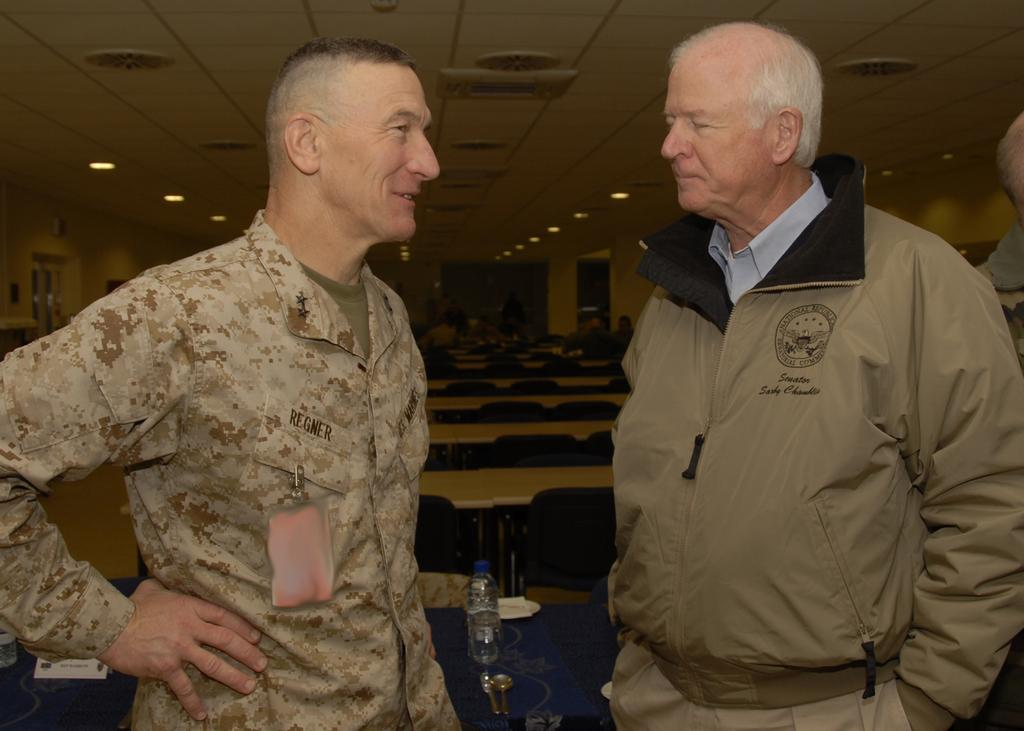How many people are in the image? There are two men in the image. What is one of the men doing in the image? One of the men is standing and laughing. What can be seen in the background of the image? There are chairs and benches in the background. What can be seen illuminated in the image? There are lights visible in the image. What type of humor is being used by the man in the image? The image does not provide enough information to determine the type of humor being used by the man. 